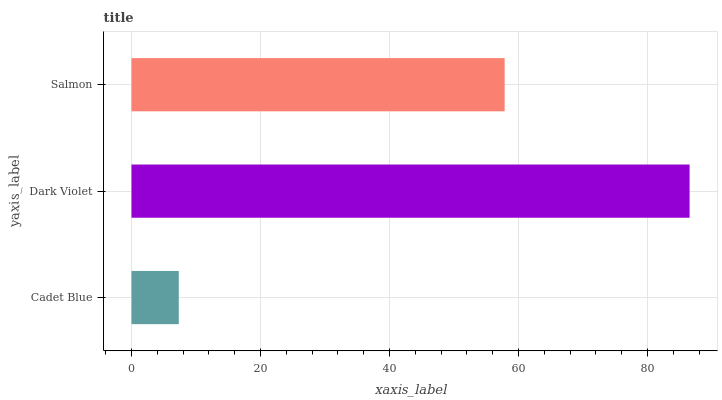Is Cadet Blue the minimum?
Answer yes or no. Yes. Is Dark Violet the maximum?
Answer yes or no. Yes. Is Salmon the minimum?
Answer yes or no. No. Is Salmon the maximum?
Answer yes or no. No. Is Dark Violet greater than Salmon?
Answer yes or no. Yes. Is Salmon less than Dark Violet?
Answer yes or no. Yes. Is Salmon greater than Dark Violet?
Answer yes or no. No. Is Dark Violet less than Salmon?
Answer yes or no. No. Is Salmon the high median?
Answer yes or no. Yes. Is Salmon the low median?
Answer yes or no. Yes. Is Cadet Blue the high median?
Answer yes or no. No. Is Cadet Blue the low median?
Answer yes or no. No. 